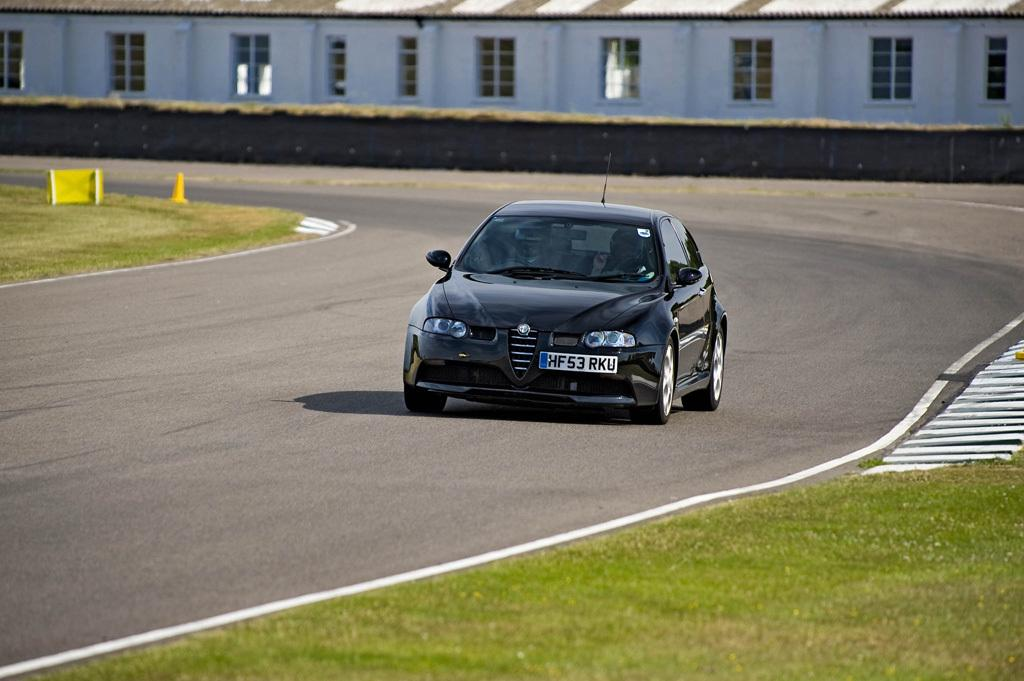What is the main subject of the image? There is a car in the image. Where is the car located? The car is on the road. What type of vegetation can be seen on both sides of the image? There is grass on the right side and the left side of the image. What can be seen in the background of the image? There is a building in the background of the image. What type of pet can be seen adjusting the car's seat in the image? There is no pet present in the image, and no adjustments to the car's seat are visible. 